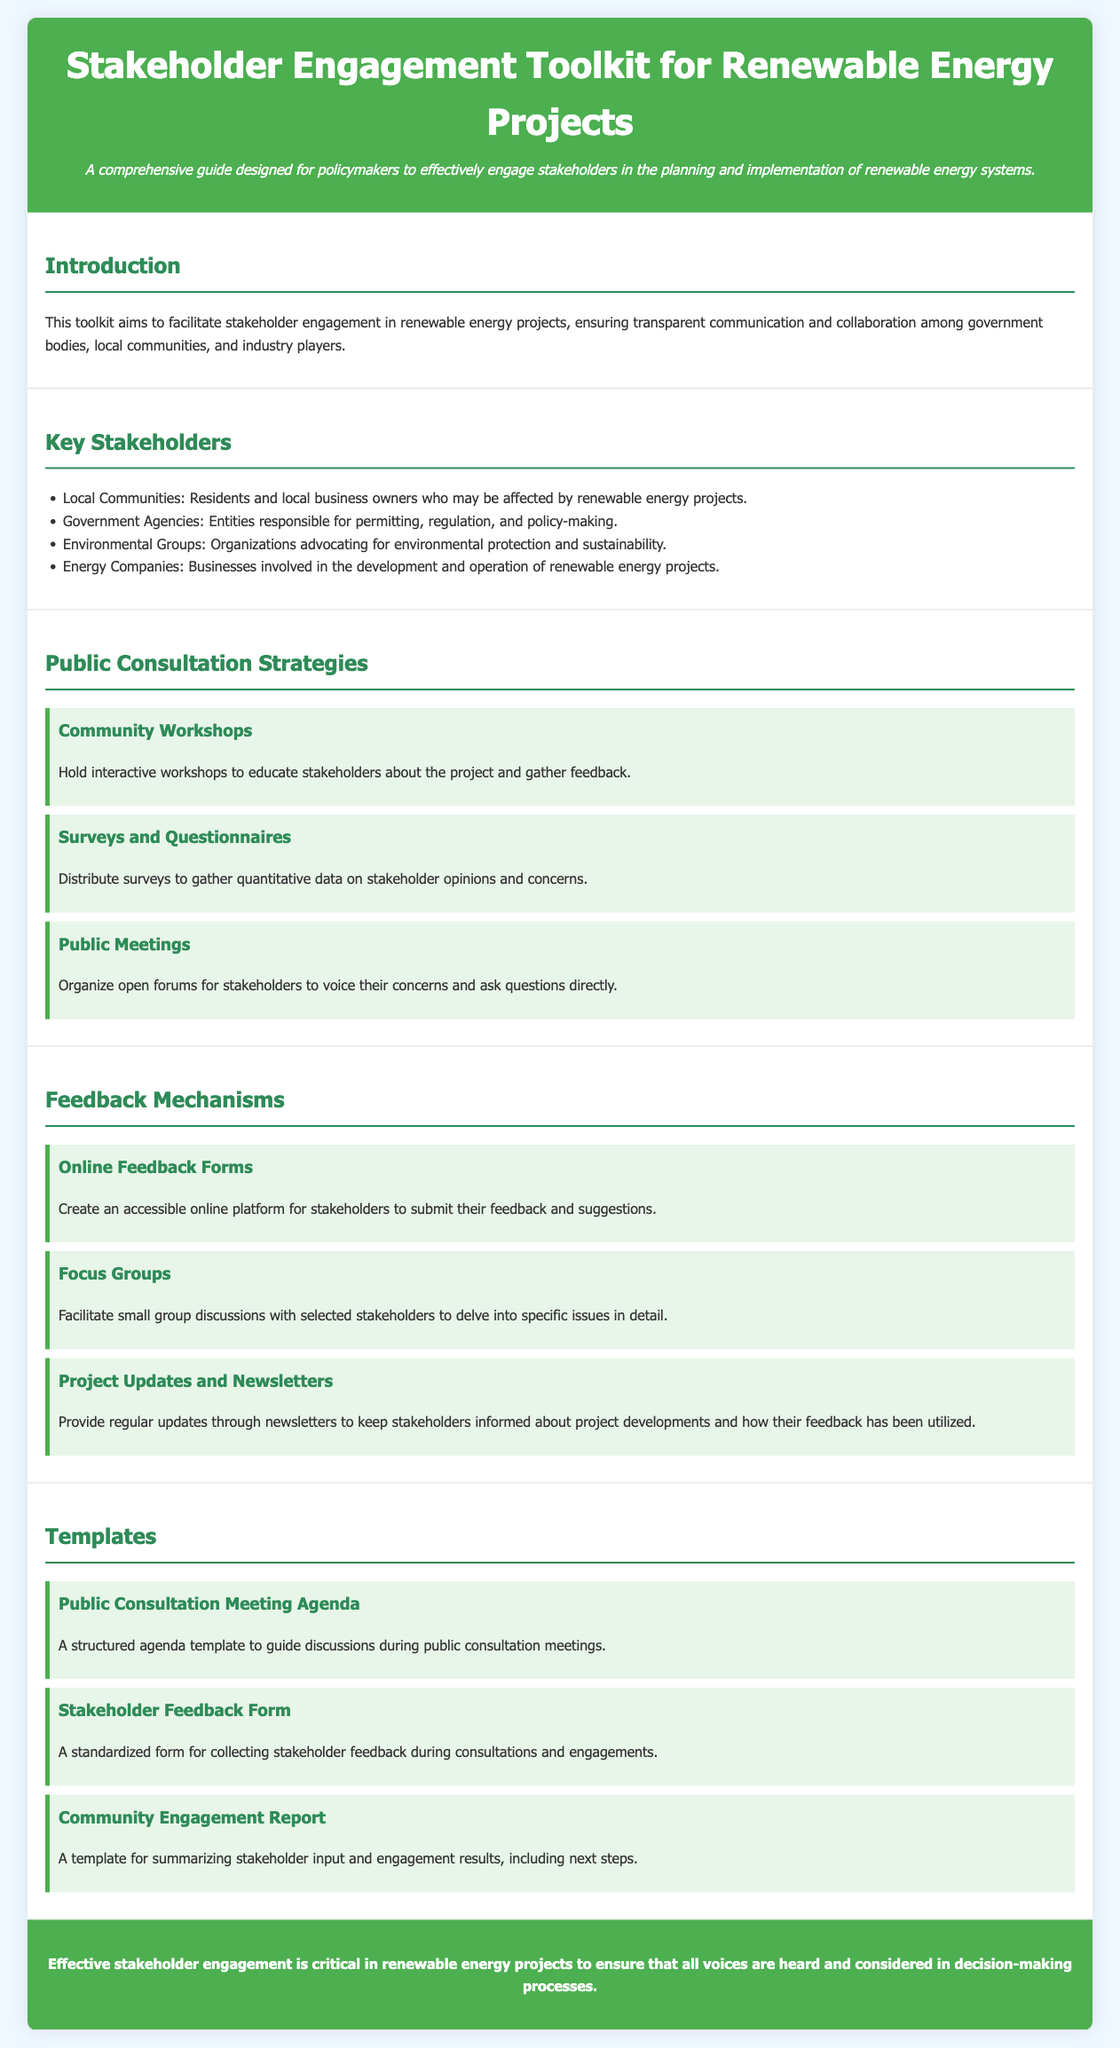What is the title of the document? The title of the document is prominently displayed at the top of the document.
Answer: Stakeholder Engagement Toolkit for Renewable Energy Projects How many key stakeholders are listed? The document lists four key stakeholders in the section dedicated to them.
Answer: Four What is one type of public consultation strategy mentioned? The document includes several public consultation strategies, one of which is highlighted in the corresponding section.
Answer: Community Workshops What is an example of a feedback mechanism? The section on feedback mechanisms includes multiple examples, one of which is specified.
Answer: Online Feedback Forms What is the purpose of the Community Engagement Report template? The template is intended for a specific function within stakeholder engagement as described in the templates section.
Answer: Summarizing stakeholder input What is the color of the header background? The background color of the header is specifically defined in the document stylesheet.
Answer: Green What should be provided through newsletters according to the feedback mechanisms? The document outlines a specific function of newsletters in keeping stakeholders informed.
Answer: Project updates Which group advocates for environmental protection? The key stakeholders section identifies organizations with specific focus areas, including one that advocates for environmental protection.
Answer: Environmental Groups What is highlighted in the conclusion of the document? The conclusion sums up a vital aspect of stakeholder engagement mentioned throughout the document.
Answer: Effective stakeholder engagement 